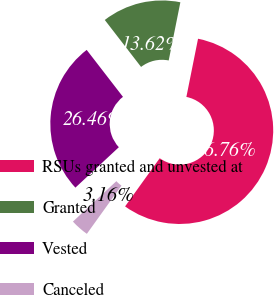<chart> <loc_0><loc_0><loc_500><loc_500><pie_chart><fcel>RSUs granted and unvested at<fcel>Granted<fcel>Vested<fcel>Canceled<nl><fcel>56.77%<fcel>13.62%<fcel>26.46%<fcel>3.16%<nl></chart> 